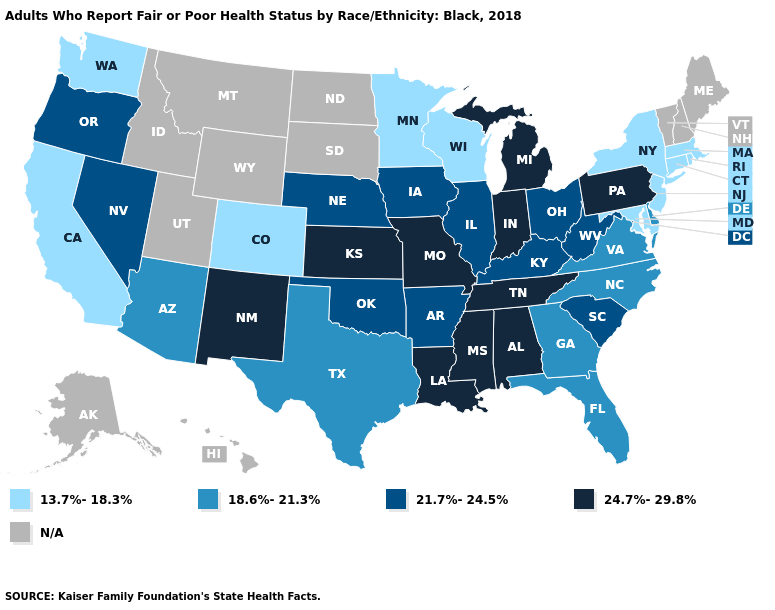Which states have the lowest value in the MidWest?
Concise answer only. Minnesota, Wisconsin. Among the states that border Wisconsin , which have the lowest value?
Keep it brief. Minnesota. What is the lowest value in the USA?
Give a very brief answer. 13.7%-18.3%. Which states have the lowest value in the West?
Concise answer only. California, Colorado, Washington. What is the value of Oklahoma?
Keep it brief. 21.7%-24.5%. What is the lowest value in the Northeast?
Keep it brief. 13.7%-18.3%. What is the highest value in the West ?
Write a very short answer. 24.7%-29.8%. Name the states that have a value in the range 13.7%-18.3%?
Short answer required. California, Colorado, Connecticut, Maryland, Massachusetts, Minnesota, New Jersey, New York, Rhode Island, Washington, Wisconsin. What is the value of Indiana?
Quick response, please. 24.7%-29.8%. Does Wisconsin have the highest value in the MidWest?
Short answer required. No. Name the states that have a value in the range 13.7%-18.3%?
Give a very brief answer. California, Colorado, Connecticut, Maryland, Massachusetts, Minnesota, New Jersey, New York, Rhode Island, Washington, Wisconsin. What is the value of Maryland?
Quick response, please. 13.7%-18.3%. Which states have the lowest value in the USA?
Give a very brief answer. California, Colorado, Connecticut, Maryland, Massachusetts, Minnesota, New Jersey, New York, Rhode Island, Washington, Wisconsin. Which states have the lowest value in the MidWest?
Concise answer only. Minnesota, Wisconsin. Does Rhode Island have the lowest value in the USA?
Short answer required. Yes. 